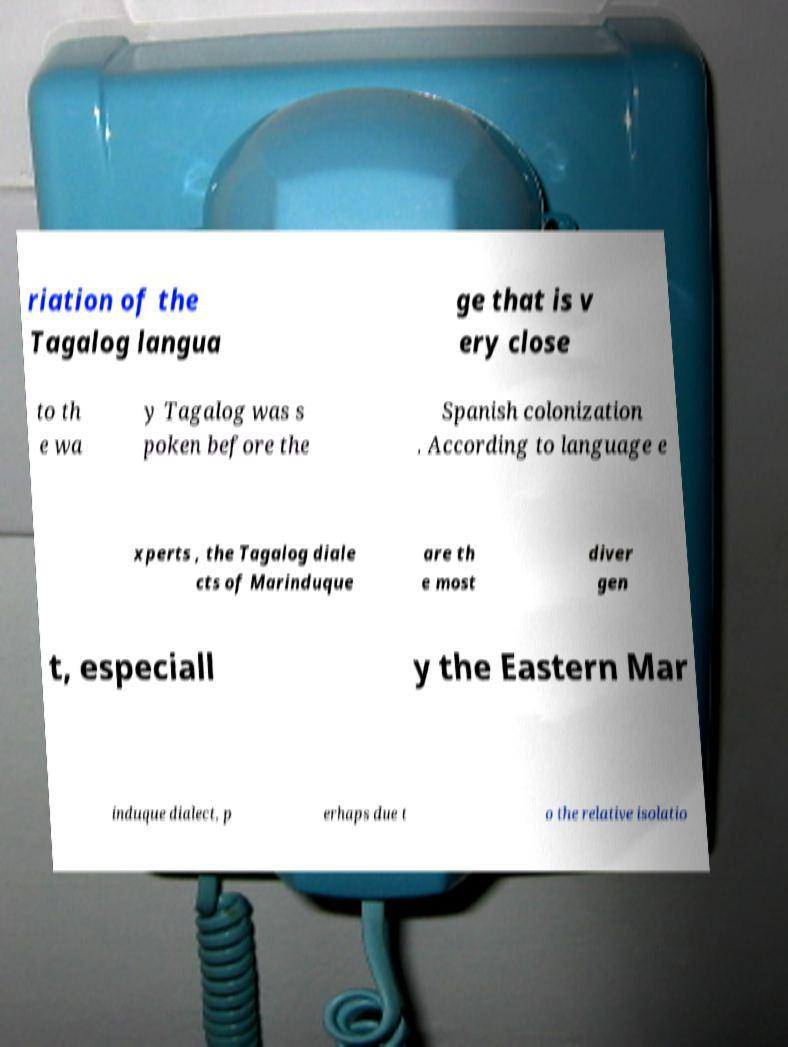For documentation purposes, I need the text within this image transcribed. Could you provide that? riation of the Tagalog langua ge that is v ery close to th e wa y Tagalog was s poken before the Spanish colonization . According to language e xperts , the Tagalog diale cts of Marinduque are th e most diver gen t, especiall y the Eastern Mar induque dialect, p erhaps due t o the relative isolatio 